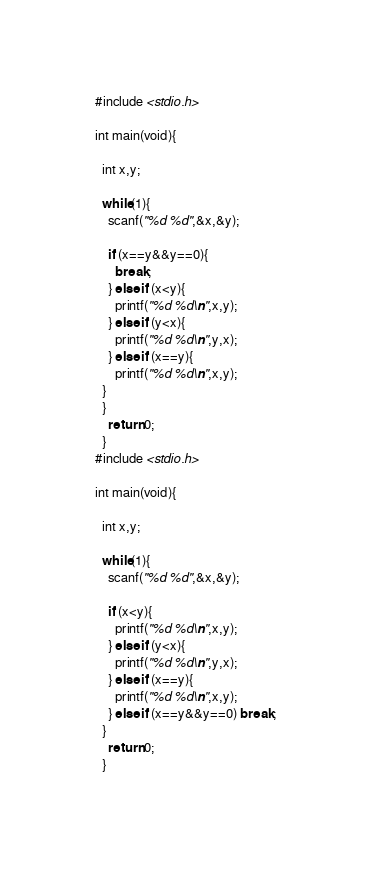<code> <loc_0><loc_0><loc_500><loc_500><_C_>#include <stdio.h>

int main(void){
  
  int x,y;

  while(1){
    scanf("%d %d",&x,&y);

    if (x==y&&y==0){
      break;
    } else if (x<y){
      printf("%d %d\n",x,y);
    } else if (y<x){
      printf("%d %d\n",y,x);
    } else if (x==y){
      printf("%d %d\n",x,y);
  }
  }
    return 0;
  }
#include <stdio.h>

int main(void){
  
  int x,y;

  while(1){
    scanf("%d %d",&x,&y);

    if (x<y){
      printf("%d %d\n",x,y);
    } else if (y<x){
      printf("%d %d\n",y,x);
    } else if (x==y){
      printf("%d %d\n",x,y);
    } else if (x==y&&y==0) break;
  }
    return 0;
  }</code> 